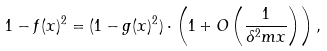Convert formula to latex. <formula><loc_0><loc_0><loc_500><loc_500>1 - f ( x ) ^ { 2 } = ( 1 - g ( x ) ^ { 2 } ) \cdot \left ( 1 + O \left ( \frac { 1 } { \delta ^ { 2 } m x } \right ) \right ) ,</formula> 